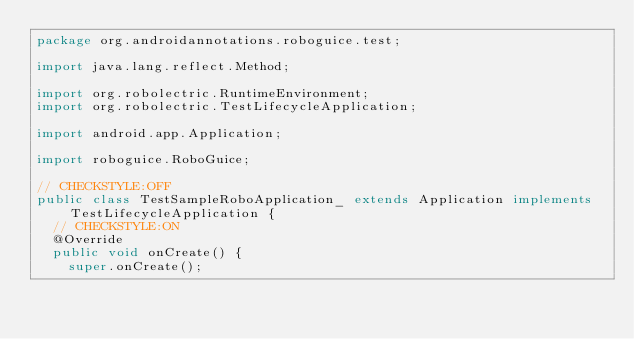<code> <loc_0><loc_0><loc_500><loc_500><_Java_>package org.androidannotations.roboguice.test;

import java.lang.reflect.Method;

import org.robolectric.RuntimeEnvironment;
import org.robolectric.TestLifecycleApplication;

import android.app.Application;

import roboguice.RoboGuice;

// CHECKSTYLE:OFF
public class TestSampleRoboApplication_ extends Application implements TestLifecycleApplication {
	// CHECKSTYLE:ON
	@Override
	public void onCreate() {
		super.onCreate();
</code> 